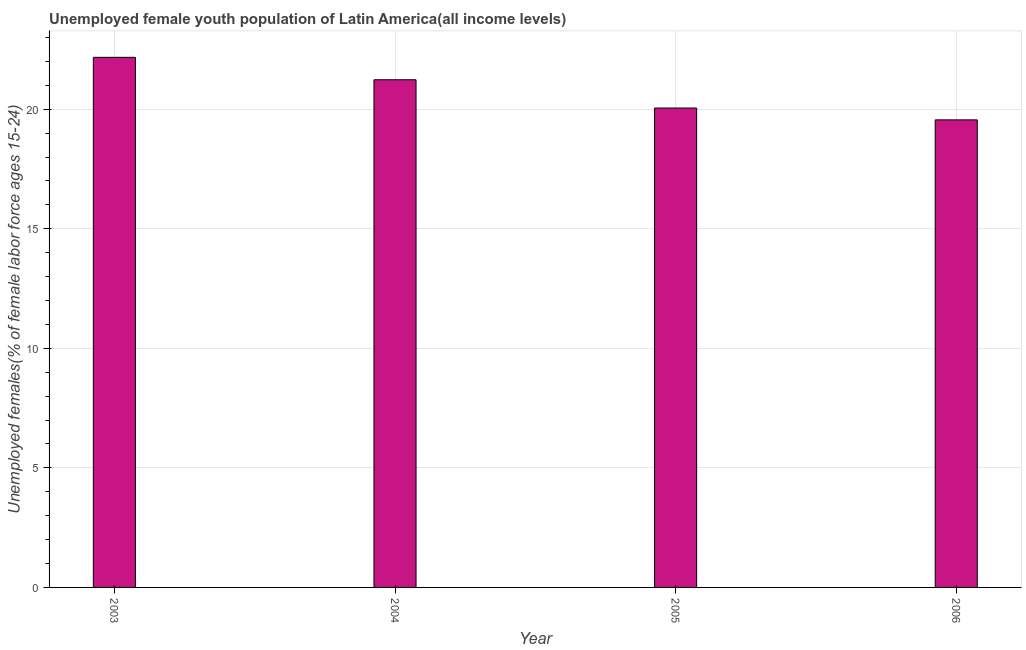Does the graph contain any zero values?
Provide a short and direct response. No. Does the graph contain grids?
Keep it short and to the point. Yes. What is the title of the graph?
Offer a very short reply. Unemployed female youth population of Latin America(all income levels). What is the label or title of the X-axis?
Your response must be concise. Year. What is the label or title of the Y-axis?
Keep it short and to the point. Unemployed females(% of female labor force ages 15-24). What is the unemployed female youth in 2006?
Provide a succinct answer. 19.56. Across all years, what is the maximum unemployed female youth?
Ensure brevity in your answer.  22.17. Across all years, what is the minimum unemployed female youth?
Offer a very short reply. 19.56. In which year was the unemployed female youth maximum?
Your answer should be very brief. 2003. What is the sum of the unemployed female youth?
Your answer should be very brief. 83.01. What is the difference between the unemployed female youth in 2004 and 2006?
Your answer should be very brief. 1.68. What is the average unemployed female youth per year?
Your response must be concise. 20.75. What is the median unemployed female youth?
Your answer should be compact. 20.64. What is the ratio of the unemployed female youth in 2003 to that in 2005?
Your response must be concise. 1.11. Is the unemployed female youth in 2003 less than that in 2004?
Make the answer very short. No. Is the difference between the unemployed female youth in 2003 and 2006 greater than the difference between any two years?
Your answer should be compact. Yes. What is the difference between the highest and the second highest unemployed female youth?
Make the answer very short. 0.94. Is the sum of the unemployed female youth in 2004 and 2005 greater than the maximum unemployed female youth across all years?
Your response must be concise. Yes. What is the difference between the highest and the lowest unemployed female youth?
Your response must be concise. 2.62. In how many years, is the unemployed female youth greater than the average unemployed female youth taken over all years?
Keep it short and to the point. 2. Are all the bars in the graph horizontal?
Provide a short and direct response. No. How many years are there in the graph?
Your response must be concise. 4. What is the Unemployed females(% of female labor force ages 15-24) of 2003?
Your answer should be very brief. 22.17. What is the Unemployed females(% of female labor force ages 15-24) of 2004?
Your answer should be very brief. 21.23. What is the Unemployed females(% of female labor force ages 15-24) of 2005?
Your answer should be very brief. 20.05. What is the Unemployed females(% of female labor force ages 15-24) of 2006?
Ensure brevity in your answer.  19.56. What is the difference between the Unemployed females(% of female labor force ages 15-24) in 2003 and 2004?
Offer a very short reply. 0.94. What is the difference between the Unemployed females(% of female labor force ages 15-24) in 2003 and 2005?
Provide a short and direct response. 2.12. What is the difference between the Unemployed females(% of female labor force ages 15-24) in 2003 and 2006?
Keep it short and to the point. 2.62. What is the difference between the Unemployed females(% of female labor force ages 15-24) in 2004 and 2005?
Ensure brevity in your answer.  1.18. What is the difference between the Unemployed females(% of female labor force ages 15-24) in 2004 and 2006?
Your answer should be compact. 1.68. What is the difference between the Unemployed females(% of female labor force ages 15-24) in 2005 and 2006?
Offer a very short reply. 0.5. What is the ratio of the Unemployed females(% of female labor force ages 15-24) in 2003 to that in 2004?
Offer a terse response. 1.04. What is the ratio of the Unemployed females(% of female labor force ages 15-24) in 2003 to that in 2005?
Keep it short and to the point. 1.11. What is the ratio of the Unemployed females(% of female labor force ages 15-24) in 2003 to that in 2006?
Ensure brevity in your answer.  1.13. What is the ratio of the Unemployed females(% of female labor force ages 15-24) in 2004 to that in 2005?
Offer a terse response. 1.06. What is the ratio of the Unemployed females(% of female labor force ages 15-24) in 2004 to that in 2006?
Your response must be concise. 1.09. 